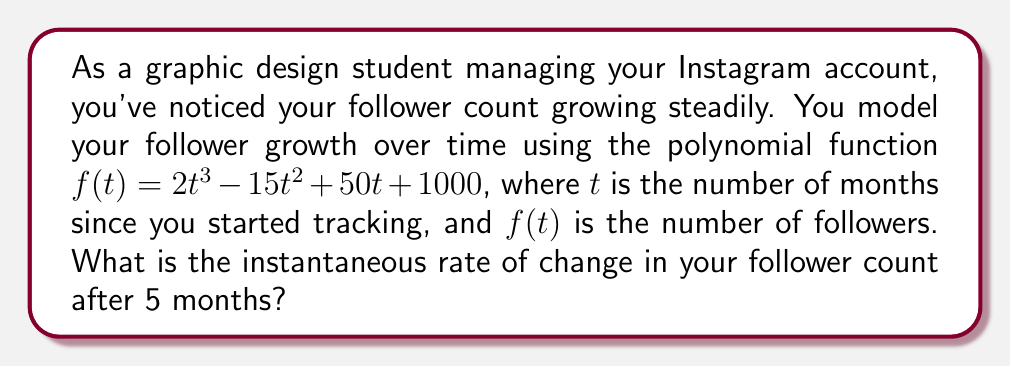Give your solution to this math problem. To find the instantaneous rate of change at $t = 5$ months, we need to calculate the derivative of the function $f(t)$ and evaluate it at $t = 5$. Here's how we do it:

1) The given function is $f(t) = 2t^3 - 15t^2 + 50t + 1000$

2) To find the derivative, we apply the power rule and constant rule:
   $$f'(t) = 6t^2 - 30t + 50$$

3) Now we evaluate $f'(t)$ at $t = 5$:
   $$f'(5) = 6(5^2) - 30(5) + 50$$

4) Simplify:
   $$f'(5) = 6(25) - 150 + 50$$
   $$f'(5) = 150 - 150 + 50$$
   $$f'(5) = 50$$

5) The result, 50, represents the instantaneous rate of change in followers per month at $t = 5$ months.
Answer: 50 followers per month 